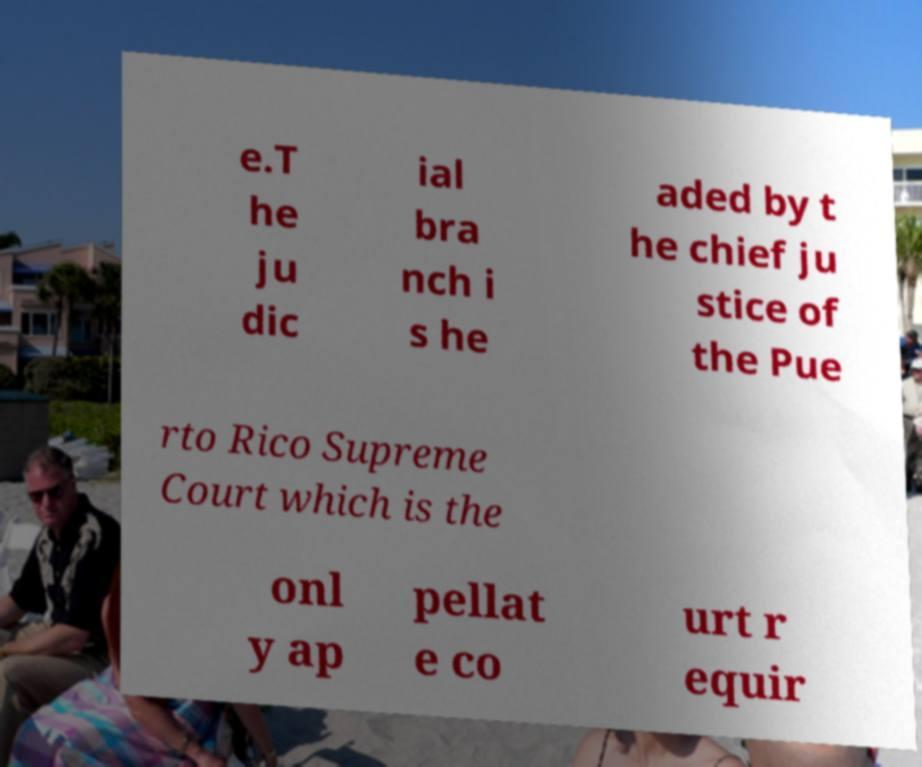For documentation purposes, I need the text within this image transcribed. Could you provide that? e.T he ju dic ial bra nch i s he aded by t he chief ju stice of the Pue rto Rico Supreme Court which is the onl y ap pellat e co urt r equir 